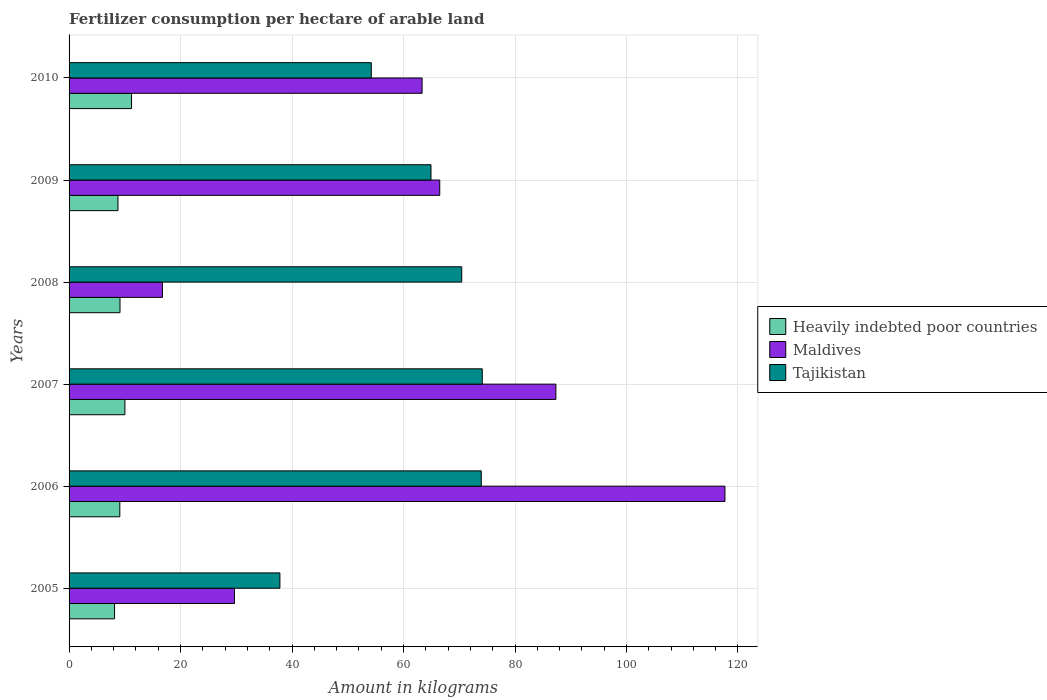How many different coloured bars are there?
Your response must be concise. 3. How many groups of bars are there?
Provide a short and direct response. 6. Are the number of bars per tick equal to the number of legend labels?
Your answer should be very brief. Yes. How many bars are there on the 4th tick from the top?
Make the answer very short. 3. What is the label of the 2nd group of bars from the top?
Your answer should be compact. 2009. In how many cases, is the number of bars for a given year not equal to the number of legend labels?
Provide a succinct answer. 0. What is the amount of fertilizer consumption in Heavily indebted poor countries in 2007?
Ensure brevity in your answer.  10.02. Across all years, what is the maximum amount of fertilizer consumption in Heavily indebted poor countries?
Give a very brief answer. 11.21. Across all years, what is the minimum amount of fertilizer consumption in Maldives?
Offer a very short reply. 16.75. What is the total amount of fertilizer consumption in Heavily indebted poor countries in the graph?
Your answer should be very brief. 56.4. What is the difference between the amount of fertilizer consumption in Tajikistan in 2007 and that in 2009?
Give a very brief answer. 9.2. What is the difference between the amount of fertilizer consumption in Tajikistan in 2006 and the amount of fertilizer consumption in Maldives in 2009?
Your response must be concise. 7.45. What is the average amount of fertilizer consumption in Heavily indebted poor countries per year?
Provide a short and direct response. 9.4. In the year 2006, what is the difference between the amount of fertilizer consumption in Tajikistan and amount of fertilizer consumption in Heavily indebted poor countries?
Offer a very short reply. 64.85. In how many years, is the amount of fertilizer consumption in Heavily indebted poor countries greater than 28 kg?
Give a very brief answer. 0. What is the ratio of the amount of fertilizer consumption in Tajikistan in 2006 to that in 2010?
Keep it short and to the point. 1.36. Is the difference between the amount of fertilizer consumption in Tajikistan in 2009 and 2010 greater than the difference between the amount of fertilizer consumption in Heavily indebted poor countries in 2009 and 2010?
Provide a succinct answer. Yes. What is the difference between the highest and the second highest amount of fertilizer consumption in Maldives?
Make the answer very short. 30.33. What is the difference between the highest and the lowest amount of fertilizer consumption in Heavily indebted poor countries?
Provide a short and direct response. 3.04. In how many years, is the amount of fertilizer consumption in Maldives greater than the average amount of fertilizer consumption in Maldives taken over all years?
Keep it short and to the point. 3. Is the sum of the amount of fertilizer consumption in Maldives in 2007 and 2010 greater than the maximum amount of fertilizer consumption in Heavily indebted poor countries across all years?
Provide a short and direct response. Yes. What does the 3rd bar from the top in 2010 represents?
Your answer should be very brief. Heavily indebted poor countries. What does the 1st bar from the bottom in 2008 represents?
Provide a succinct answer. Heavily indebted poor countries. How many bars are there?
Give a very brief answer. 18. Are all the bars in the graph horizontal?
Provide a short and direct response. Yes. What is the difference between two consecutive major ticks on the X-axis?
Your answer should be compact. 20. Are the values on the major ticks of X-axis written in scientific E-notation?
Offer a terse response. No. Does the graph contain any zero values?
Your response must be concise. No. Does the graph contain grids?
Keep it short and to the point. Yes. Where does the legend appear in the graph?
Your answer should be very brief. Center right. How are the legend labels stacked?
Ensure brevity in your answer.  Vertical. What is the title of the graph?
Provide a short and direct response. Fertilizer consumption per hectare of arable land. What is the label or title of the X-axis?
Provide a short and direct response. Amount in kilograms. What is the label or title of the Y-axis?
Offer a terse response. Years. What is the Amount in kilograms of Heavily indebted poor countries in 2005?
Offer a terse response. 8.16. What is the Amount in kilograms in Maldives in 2005?
Your answer should be very brief. 29.67. What is the Amount in kilograms of Tajikistan in 2005?
Your answer should be compact. 37.82. What is the Amount in kilograms in Heavily indebted poor countries in 2006?
Give a very brief answer. 9.1. What is the Amount in kilograms in Maldives in 2006?
Ensure brevity in your answer.  117.67. What is the Amount in kilograms in Tajikistan in 2006?
Offer a terse response. 73.95. What is the Amount in kilograms of Heavily indebted poor countries in 2007?
Ensure brevity in your answer.  10.02. What is the Amount in kilograms of Maldives in 2007?
Make the answer very short. 87.33. What is the Amount in kilograms in Tajikistan in 2007?
Give a very brief answer. 74.13. What is the Amount in kilograms in Heavily indebted poor countries in 2008?
Give a very brief answer. 9.14. What is the Amount in kilograms of Maldives in 2008?
Provide a succinct answer. 16.75. What is the Amount in kilograms in Tajikistan in 2008?
Your answer should be very brief. 70.45. What is the Amount in kilograms of Heavily indebted poor countries in 2009?
Offer a terse response. 8.77. What is the Amount in kilograms of Maldives in 2009?
Offer a terse response. 66.5. What is the Amount in kilograms of Tajikistan in 2009?
Give a very brief answer. 64.93. What is the Amount in kilograms in Heavily indebted poor countries in 2010?
Your answer should be compact. 11.21. What is the Amount in kilograms of Maldives in 2010?
Make the answer very short. 63.33. What is the Amount in kilograms of Tajikistan in 2010?
Your answer should be compact. 54.22. Across all years, what is the maximum Amount in kilograms in Heavily indebted poor countries?
Provide a succinct answer. 11.21. Across all years, what is the maximum Amount in kilograms in Maldives?
Keep it short and to the point. 117.67. Across all years, what is the maximum Amount in kilograms of Tajikistan?
Your answer should be very brief. 74.13. Across all years, what is the minimum Amount in kilograms in Heavily indebted poor countries?
Provide a succinct answer. 8.16. Across all years, what is the minimum Amount in kilograms of Maldives?
Ensure brevity in your answer.  16.75. Across all years, what is the minimum Amount in kilograms of Tajikistan?
Offer a terse response. 37.82. What is the total Amount in kilograms of Heavily indebted poor countries in the graph?
Keep it short and to the point. 56.4. What is the total Amount in kilograms in Maldives in the graph?
Give a very brief answer. 381.25. What is the total Amount in kilograms in Tajikistan in the graph?
Make the answer very short. 375.49. What is the difference between the Amount in kilograms in Heavily indebted poor countries in 2005 and that in 2006?
Offer a terse response. -0.94. What is the difference between the Amount in kilograms in Maldives in 2005 and that in 2006?
Your answer should be compact. -88. What is the difference between the Amount in kilograms in Tajikistan in 2005 and that in 2006?
Your answer should be compact. -36.12. What is the difference between the Amount in kilograms in Heavily indebted poor countries in 2005 and that in 2007?
Give a very brief answer. -1.86. What is the difference between the Amount in kilograms of Maldives in 2005 and that in 2007?
Give a very brief answer. -57.67. What is the difference between the Amount in kilograms of Tajikistan in 2005 and that in 2007?
Your response must be concise. -36.3. What is the difference between the Amount in kilograms of Heavily indebted poor countries in 2005 and that in 2008?
Your response must be concise. -0.98. What is the difference between the Amount in kilograms in Maldives in 2005 and that in 2008?
Your answer should be very brief. 12.92. What is the difference between the Amount in kilograms in Tajikistan in 2005 and that in 2008?
Give a very brief answer. -32.62. What is the difference between the Amount in kilograms in Heavily indebted poor countries in 2005 and that in 2009?
Your answer should be compact. -0.61. What is the difference between the Amount in kilograms of Maldives in 2005 and that in 2009?
Make the answer very short. -36.83. What is the difference between the Amount in kilograms of Tajikistan in 2005 and that in 2009?
Offer a terse response. -27.1. What is the difference between the Amount in kilograms in Heavily indebted poor countries in 2005 and that in 2010?
Provide a short and direct response. -3.04. What is the difference between the Amount in kilograms of Maldives in 2005 and that in 2010?
Your response must be concise. -33.67. What is the difference between the Amount in kilograms of Tajikistan in 2005 and that in 2010?
Ensure brevity in your answer.  -16.39. What is the difference between the Amount in kilograms in Heavily indebted poor countries in 2006 and that in 2007?
Your response must be concise. -0.92. What is the difference between the Amount in kilograms in Maldives in 2006 and that in 2007?
Your answer should be very brief. 30.33. What is the difference between the Amount in kilograms of Tajikistan in 2006 and that in 2007?
Provide a succinct answer. -0.18. What is the difference between the Amount in kilograms in Heavily indebted poor countries in 2006 and that in 2008?
Provide a succinct answer. -0.03. What is the difference between the Amount in kilograms of Maldives in 2006 and that in 2008?
Provide a short and direct response. 100.92. What is the difference between the Amount in kilograms in Tajikistan in 2006 and that in 2008?
Offer a terse response. 3.5. What is the difference between the Amount in kilograms of Heavily indebted poor countries in 2006 and that in 2009?
Provide a succinct answer. 0.33. What is the difference between the Amount in kilograms in Maldives in 2006 and that in 2009?
Your answer should be very brief. 51.17. What is the difference between the Amount in kilograms of Tajikistan in 2006 and that in 2009?
Offer a terse response. 9.02. What is the difference between the Amount in kilograms in Heavily indebted poor countries in 2006 and that in 2010?
Your answer should be very brief. -2.1. What is the difference between the Amount in kilograms of Maldives in 2006 and that in 2010?
Your response must be concise. 54.33. What is the difference between the Amount in kilograms of Tajikistan in 2006 and that in 2010?
Your answer should be compact. 19.73. What is the difference between the Amount in kilograms in Heavily indebted poor countries in 2007 and that in 2008?
Ensure brevity in your answer.  0.88. What is the difference between the Amount in kilograms of Maldives in 2007 and that in 2008?
Your response must be concise. 70.58. What is the difference between the Amount in kilograms in Tajikistan in 2007 and that in 2008?
Make the answer very short. 3.68. What is the difference between the Amount in kilograms in Heavily indebted poor countries in 2007 and that in 2009?
Offer a very short reply. 1.24. What is the difference between the Amount in kilograms in Maldives in 2007 and that in 2009?
Provide a succinct answer. 20.83. What is the difference between the Amount in kilograms in Tajikistan in 2007 and that in 2009?
Provide a succinct answer. 9.2. What is the difference between the Amount in kilograms of Heavily indebted poor countries in 2007 and that in 2010?
Keep it short and to the point. -1.19. What is the difference between the Amount in kilograms of Maldives in 2007 and that in 2010?
Give a very brief answer. 24. What is the difference between the Amount in kilograms of Tajikistan in 2007 and that in 2010?
Your answer should be compact. 19.91. What is the difference between the Amount in kilograms of Heavily indebted poor countries in 2008 and that in 2009?
Your answer should be compact. 0.36. What is the difference between the Amount in kilograms of Maldives in 2008 and that in 2009?
Your response must be concise. -49.75. What is the difference between the Amount in kilograms of Tajikistan in 2008 and that in 2009?
Make the answer very short. 5.52. What is the difference between the Amount in kilograms of Heavily indebted poor countries in 2008 and that in 2010?
Provide a succinct answer. -2.07. What is the difference between the Amount in kilograms in Maldives in 2008 and that in 2010?
Your response must be concise. -46.58. What is the difference between the Amount in kilograms in Tajikistan in 2008 and that in 2010?
Offer a terse response. 16.23. What is the difference between the Amount in kilograms in Heavily indebted poor countries in 2009 and that in 2010?
Give a very brief answer. -2.43. What is the difference between the Amount in kilograms in Maldives in 2009 and that in 2010?
Offer a very short reply. 3.17. What is the difference between the Amount in kilograms of Tajikistan in 2009 and that in 2010?
Offer a very short reply. 10.71. What is the difference between the Amount in kilograms in Heavily indebted poor countries in 2005 and the Amount in kilograms in Maldives in 2006?
Make the answer very short. -109.5. What is the difference between the Amount in kilograms in Heavily indebted poor countries in 2005 and the Amount in kilograms in Tajikistan in 2006?
Your answer should be compact. -65.79. What is the difference between the Amount in kilograms of Maldives in 2005 and the Amount in kilograms of Tajikistan in 2006?
Your answer should be compact. -44.28. What is the difference between the Amount in kilograms of Heavily indebted poor countries in 2005 and the Amount in kilograms of Maldives in 2007?
Provide a short and direct response. -79.17. What is the difference between the Amount in kilograms of Heavily indebted poor countries in 2005 and the Amount in kilograms of Tajikistan in 2007?
Your answer should be compact. -65.97. What is the difference between the Amount in kilograms of Maldives in 2005 and the Amount in kilograms of Tajikistan in 2007?
Give a very brief answer. -44.46. What is the difference between the Amount in kilograms of Heavily indebted poor countries in 2005 and the Amount in kilograms of Maldives in 2008?
Your answer should be compact. -8.59. What is the difference between the Amount in kilograms in Heavily indebted poor countries in 2005 and the Amount in kilograms in Tajikistan in 2008?
Offer a very short reply. -62.28. What is the difference between the Amount in kilograms in Maldives in 2005 and the Amount in kilograms in Tajikistan in 2008?
Offer a terse response. -40.78. What is the difference between the Amount in kilograms of Heavily indebted poor countries in 2005 and the Amount in kilograms of Maldives in 2009?
Keep it short and to the point. -58.34. What is the difference between the Amount in kilograms of Heavily indebted poor countries in 2005 and the Amount in kilograms of Tajikistan in 2009?
Offer a very short reply. -56.77. What is the difference between the Amount in kilograms of Maldives in 2005 and the Amount in kilograms of Tajikistan in 2009?
Offer a very short reply. -35.26. What is the difference between the Amount in kilograms of Heavily indebted poor countries in 2005 and the Amount in kilograms of Maldives in 2010?
Ensure brevity in your answer.  -55.17. What is the difference between the Amount in kilograms in Heavily indebted poor countries in 2005 and the Amount in kilograms in Tajikistan in 2010?
Your answer should be very brief. -46.06. What is the difference between the Amount in kilograms in Maldives in 2005 and the Amount in kilograms in Tajikistan in 2010?
Provide a short and direct response. -24.55. What is the difference between the Amount in kilograms in Heavily indebted poor countries in 2006 and the Amount in kilograms in Maldives in 2007?
Your answer should be compact. -78.23. What is the difference between the Amount in kilograms in Heavily indebted poor countries in 2006 and the Amount in kilograms in Tajikistan in 2007?
Your answer should be very brief. -65.03. What is the difference between the Amount in kilograms of Maldives in 2006 and the Amount in kilograms of Tajikistan in 2007?
Your answer should be very brief. 43.54. What is the difference between the Amount in kilograms of Heavily indebted poor countries in 2006 and the Amount in kilograms of Maldives in 2008?
Your answer should be very brief. -7.65. What is the difference between the Amount in kilograms of Heavily indebted poor countries in 2006 and the Amount in kilograms of Tajikistan in 2008?
Your answer should be very brief. -61.34. What is the difference between the Amount in kilograms of Maldives in 2006 and the Amount in kilograms of Tajikistan in 2008?
Provide a short and direct response. 47.22. What is the difference between the Amount in kilograms of Heavily indebted poor countries in 2006 and the Amount in kilograms of Maldives in 2009?
Make the answer very short. -57.4. What is the difference between the Amount in kilograms of Heavily indebted poor countries in 2006 and the Amount in kilograms of Tajikistan in 2009?
Give a very brief answer. -55.82. What is the difference between the Amount in kilograms of Maldives in 2006 and the Amount in kilograms of Tajikistan in 2009?
Your response must be concise. 52.74. What is the difference between the Amount in kilograms in Heavily indebted poor countries in 2006 and the Amount in kilograms in Maldives in 2010?
Your answer should be compact. -54.23. What is the difference between the Amount in kilograms of Heavily indebted poor countries in 2006 and the Amount in kilograms of Tajikistan in 2010?
Provide a short and direct response. -45.12. What is the difference between the Amount in kilograms of Maldives in 2006 and the Amount in kilograms of Tajikistan in 2010?
Give a very brief answer. 63.45. What is the difference between the Amount in kilograms of Heavily indebted poor countries in 2007 and the Amount in kilograms of Maldives in 2008?
Make the answer very short. -6.73. What is the difference between the Amount in kilograms of Heavily indebted poor countries in 2007 and the Amount in kilograms of Tajikistan in 2008?
Give a very brief answer. -60.43. What is the difference between the Amount in kilograms of Maldives in 2007 and the Amount in kilograms of Tajikistan in 2008?
Make the answer very short. 16.89. What is the difference between the Amount in kilograms in Heavily indebted poor countries in 2007 and the Amount in kilograms in Maldives in 2009?
Your answer should be compact. -56.48. What is the difference between the Amount in kilograms of Heavily indebted poor countries in 2007 and the Amount in kilograms of Tajikistan in 2009?
Your answer should be very brief. -54.91. What is the difference between the Amount in kilograms in Maldives in 2007 and the Amount in kilograms in Tajikistan in 2009?
Ensure brevity in your answer.  22.41. What is the difference between the Amount in kilograms in Heavily indebted poor countries in 2007 and the Amount in kilograms in Maldives in 2010?
Your answer should be compact. -53.32. What is the difference between the Amount in kilograms of Heavily indebted poor countries in 2007 and the Amount in kilograms of Tajikistan in 2010?
Give a very brief answer. -44.2. What is the difference between the Amount in kilograms of Maldives in 2007 and the Amount in kilograms of Tajikistan in 2010?
Make the answer very short. 33.11. What is the difference between the Amount in kilograms in Heavily indebted poor countries in 2008 and the Amount in kilograms in Maldives in 2009?
Keep it short and to the point. -57.36. What is the difference between the Amount in kilograms in Heavily indebted poor countries in 2008 and the Amount in kilograms in Tajikistan in 2009?
Offer a terse response. -55.79. What is the difference between the Amount in kilograms in Maldives in 2008 and the Amount in kilograms in Tajikistan in 2009?
Ensure brevity in your answer.  -48.18. What is the difference between the Amount in kilograms of Heavily indebted poor countries in 2008 and the Amount in kilograms of Maldives in 2010?
Offer a very short reply. -54.2. What is the difference between the Amount in kilograms of Heavily indebted poor countries in 2008 and the Amount in kilograms of Tajikistan in 2010?
Make the answer very short. -45.08. What is the difference between the Amount in kilograms in Maldives in 2008 and the Amount in kilograms in Tajikistan in 2010?
Offer a very short reply. -37.47. What is the difference between the Amount in kilograms of Heavily indebted poor countries in 2009 and the Amount in kilograms of Maldives in 2010?
Keep it short and to the point. -54.56. What is the difference between the Amount in kilograms in Heavily indebted poor countries in 2009 and the Amount in kilograms in Tajikistan in 2010?
Your response must be concise. -45.45. What is the difference between the Amount in kilograms of Maldives in 2009 and the Amount in kilograms of Tajikistan in 2010?
Your response must be concise. 12.28. What is the average Amount in kilograms of Heavily indebted poor countries per year?
Ensure brevity in your answer.  9.4. What is the average Amount in kilograms of Maldives per year?
Keep it short and to the point. 63.54. What is the average Amount in kilograms in Tajikistan per year?
Your answer should be compact. 62.58. In the year 2005, what is the difference between the Amount in kilograms in Heavily indebted poor countries and Amount in kilograms in Maldives?
Make the answer very short. -21.5. In the year 2005, what is the difference between the Amount in kilograms of Heavily indebted poor countries and Amount in kilograms of Tajikistan?
Provide a short and direct response. -29.66. In the year 2005, what is the difference between the Amount in kilograms of Maldives and Amount in kilograms of Tajikistan?
Your answer should be very brief. -8.16. In the year 2006, what is the difference between the Amount in kilograms in Heavily indebted poor countries and Amount in kilograms in Maldives?
Provide a short and direct response. -108.56. In the year 2006, what is the difference between the Amount in kilograms in Heavily indebted poor countries and Amount in kilograms in Tajikistan?
Your response must be concise. -64.85. In the year 2006, what is the difference between the Amount in kilograms of Maldives and Amount in kilograms of Tajikistan?
Your answer should be very brief. 43.72. In the year 2007, what is the difference between the Amount in kilograms in Heavily indebted poor countries and Amount in kilograms in Maldives?
Provide a short and direct response. -77.32. In the year 2007, what is the difference between the Amount in kilograms in Heavily indebted poor countries and Amount in kilograms in Tajikistan?
Your answer should be very brief. -64.11. In the year 2007, what is the difference between the Amount in kilograms in Maldives and Amount in kilograms in Tajikistan?
Offer a very short reply. 13.2. In the year 2008, what is the difference between the Amount in kilograms of Heavily indebted poor countries and Amount in kilograms of Maldives?
Provide a short and direct response. -7.61. In the year 2008, what is the difference between the Amount in kilograms of Heavily indebted poor countries and Amount in kilograms of Tajikistan?
Give a very brief answer. -61.31. In the year 2008, what is the difference between the Amount in kilograms of Maldives and Amount in kilograms of Tajikistan?
Your answer should be very brief. -53.7. In the year 2009, what is the difference between the Amount in kilograms in Heavily indebted poor countries and Amount in kilograms in Maldives?
Your answer should be compact. -57.73. In the year 2009, what is the difference between the Amount in kilograms of Heavily indebted poor countries and Amount in kilograms of Tajikistan?
Your answer should be very brief. -56.15. In the year 2009, what is the difference between the Amount in kilograms of Maldives and Amount in kilograms of Tajikistan?
Keep it short and to the point. 1.57. In the year 2010, what is the difference between the Amount in kilograms of Heavily indebted poor countries and Amount in kilograms of Maldives?
Make the answer very short. -52.13. In the year 2010, what is the difference between the Amount in kilograms of Heavily indebted poor countries and Amount in kilograms of Tajikistan?
Offer a very short reply. -43.01. In the year 2010, what is the difference between the Amount in kilograms of Maldives and Amount in kilograms of Tajikistan?
Your answer should be compact. 9.11. What is the ratio of the Amount in kilograms of Heavily indebted poor countries in 2005 to that in 2006?
Offer a terse response. 0.9. What is the ratio of the Amount in kilograms in Maldives in 2005 to that in 2006?
Offer a terse response. 0.25. What is the ratio of the Amount in kilograms in Tajikistan in 2005 to that in 2006?
Provide a succinct answer. 0.51. What is the ratio of the Amount in kilograms of Heavily indebted poor countries in 2005 to that in 2007?
Provide a short and direct response. 0.81. What is the ratio of the Amount in kilograms of Maldives in 2005 to that in 2007?
Give a very brief answer. 0.34. What is the ratio of the Amount in kilograms of Tajikistan in 2005 to that in 2007?
Make the answer very short. 0.51. What is the ratio of the Amount in kilograms of Heavily indebted poor countries in 2005 to that in 2008?
Provide a short and direct response. 0.89. What is the ratio of the Amount in kilograms of Maldives in 2005 to that in 2008?
Your answer should be very brief. 1.77. What is the ratio of the Amount in kilograms in Tajikistan in 2005 to that in 2008?
Offer a very short reply. 0.54. What is the ratio of the Amount in kilograms of Heavily indebted poor countries in 2005 to that in 2009?
Offer a terse response. 0.93. What is the ratio of the Amount in kilograms of Maldives in 2005 to that in 2009?
Provide a succinct answer. 0.45. What is the ratio of the Amount in kilograms in Tajikistan in 2005 to that in 2009?
Your answer should be very brief. 0.58. What is the ratio of the Amount in kilograms in Heavily indebted poor countries in 2005 to that in 2010?
Ensure brevity in your answer.  0.73. What is the ratio of the Amount in kilograms of Maldives in 2005 to that in 2010?
Your response must be concise. 0.47. What is the ratio of the Amount in kilograms in Tajikistan in 2005 to that in 2010?
Your response must be concise. 0.7. What is the ratio of the Amount in kilograms of Heavily indebted poor countries in 2006 to that in 2007?
Your response must be concise. 0.91. What is the ratio of the Amount in kilograms of Maldives in 2006 to that in 2007?
Your answer should be very brief. 1.35. What is the ratio of the Amount in kilograms in Maldives in 2006 to that in 2008?
Keep it short and to the point. 7.02. What is the ratio of the Amount in kilograms of Tajikistan in 2006 to that in 2008?
Your answer should be compact. 1.05. What is the ratio of the Amount in kilograms of Heavily indebted poor countries in 2006 to that in 2009?
Ensure brevity in your answer.  1.04. What is the ratio of the Amount in kilograms in Maldives in 2006 to that in 2009?
Provide a succinct answer. 1.77. What is the ratio of the Amount in kilograms in Tajikistan in 2006 to that in 2009?
Keep it short and to the point. 1.14. What is the ratio of the Amount in kilograms in Heavily indebted poor countries in 2006 to that in 2010?
Keep it short and to the point. 0.81. What is the ratio of the Amount in kilograms in Maldives in 2006 to that in 2010?
Your answer should be very brief. 1.86. What is the ratio of the Amount in kilograms in Tajikistan in 2006 to that in 2010?
Give a very brief answer. 1.36. What is the ratio of the Amount in kilograms in Heavily indebted poor countries in 2007 to that in 2008?
Your answer should be very brief. 1.1. What is the ratio of the Amount in kilograms of Maldives in 2007 to that in 2008?
Your answer should be compact. 5.21. What is the ratio of the Amount in kilograms in Tajikistan in 2007 to that in 2008?
Your response must be concise. 1.05. What is the ratio of the Amount in kilograms of Heavily indebted poor countries in 2007 to that in 2009?
Provide a succinct answer. 1.14. What is the ratio of the Amount in kilograms in Maldives in 2007 to that in 2009?
Provide a short and direct response. 1.31. What is the ratio of the Amount in kilograms in Tajikistan in 2007 to that in 2009?
Your answer should be very brief. 1.14. What is the ratio of the Amount in kilograms of Heavily indebted poor countries in 2007 to that in 2010?
Your answer should be compact. 0.89. What is the ratio of the Amount in kilograms in Maldives in 2007 to that in 2010?
Your answer should be very brief. 1.38. What is the ratio of the Amount in kilograms of Tajikistan in 2007 to that in 2010?
Provide a succinct answer. 1.37. What is the ratio of the Amount in kilograms in Heavily indebted poor countries in 2008 to that in 2009?
Ensure brevity in your answer.  1.04. What is the ratio of the Amount in kilograms in Maldives in 2008 to that in 2009?
Your answer should be very brief. 0.25. What is the ratio of the Amount in kilograms in Tajikistan in 2008 to that in 2009?
Offer a terse response. 1.08. What is the ratio of the Amount in kilograms in Heavily indebted poor countries in 2008 to that in 2010?
Ensure brevity in your answer.  0.82. What is the ratio of the Amount in kilograms of Maldives in 2008 to that in 2010?
Your answer should be compact. 0.26. What is the ratio of the Amount in kilograms of Tajikistan in 2008 to that in 2010?
Your answer should be compact. 1.3. What is the ratio of the Amount in kilograms in Heavily indebted poor countries in 2009 to that in 2010?
Your response must be concise. 0.78. What is the ratio of the Amount in kilograms of Tajikistan in 2009 to that in 2010?
Your answer should be compact. 1.2. What is the difference between the highest and the second highest Amount in kilograms in Heavily indebted poor countries?
Make the answer very short. 1.19. What is the difference between the highest and the second highest Amount in kilograms of Maldives?
Keep it short and to the point. 30.33. What is the difference between the highest and the second highest Amount in kilograms in Tajikistan?
Offer a terse response. 0.18. What is the difference between the highest and the lowest Amount in kilograms of Heavily indebted poor countries?
Provide a succinct answer. 3.04. What is the difference between the highest and the lowest Amount in kilograms in Maldives?
Provide a succinct answer. 100.92. What is the difference between the highest and the lowest Amount in kilograms of Tajikistan?
Give a very brief answer. 36.3. 